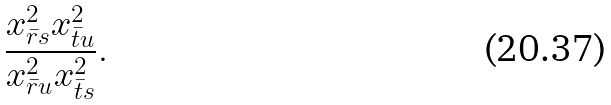Convert formula to latex. <formula><loc_0><loc_0><loc_500><loc_500>\frac { x _ { \bar { r } s } ^ { 2 } x _ { \bar { t } u } ^ { 2 } } { x _ { \bar { r } u } ^ { 2 } x _ { \bar { t } s } ^ { 2 } } .</formula> 